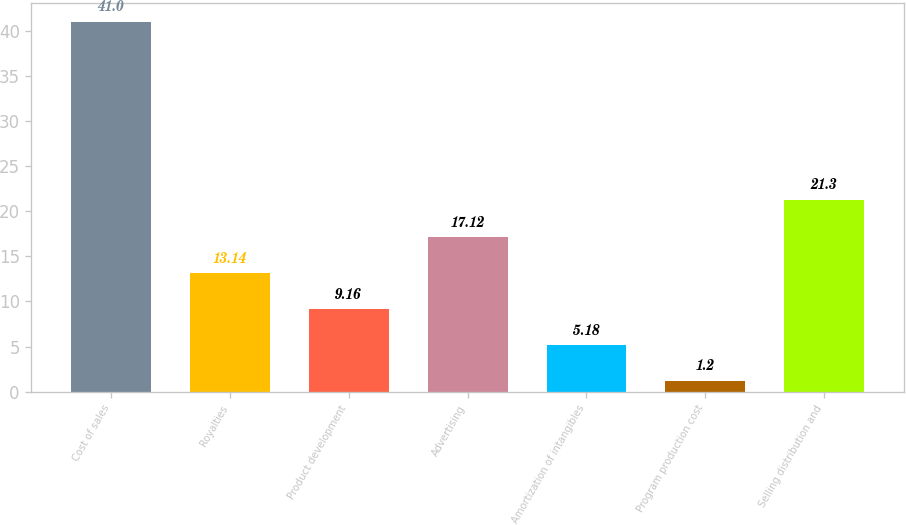Convert chart to OTSL. <chart><loc_0><loc_0><loc_500><loc_500><bar_chart><fcel>Cost of sales<fcel>Royalties<fcel>Product development<fcel>Advertising<fcel>Amortization of intangibles<fcel>Program production cost<fcel>Selling distribution and<nl><fcel>41<fcel>13.14<fcel>9.16<fcel>17.12<fcel>5.18<fcel>1.2<fcel>21.3<nl></chart> 